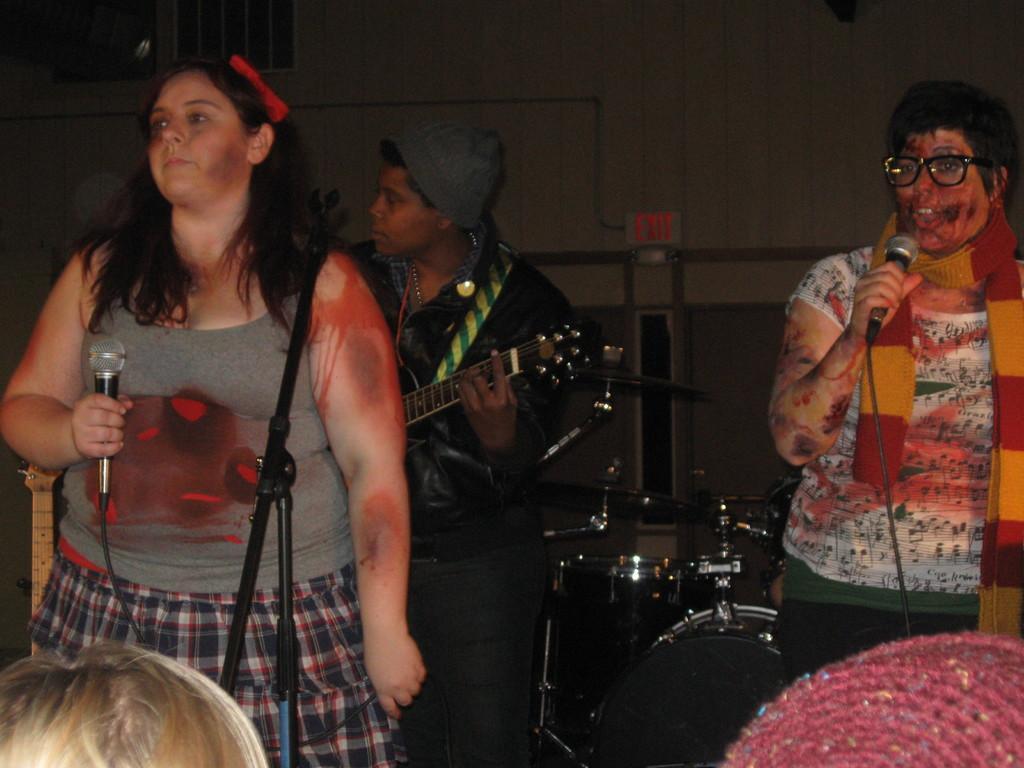In one or two sentences, can you explain what this image depicts? In this image there is a woman standing by holding a mike, another person standing and playing a guitar , another woman standing and singing a song in the microphone , and at the back ground there are drums, group of people, wall. 